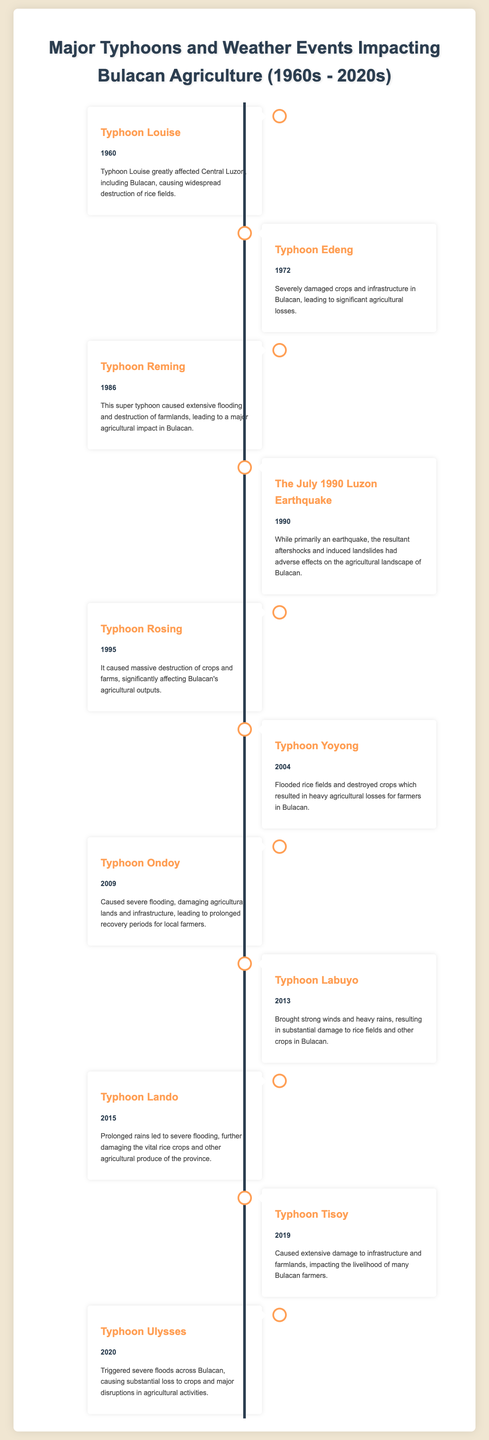What year did Typhoon Louise occur? The document states that Typhoon Louise occurred in the year 1960.
Answer: 1960 Which typhoon caused severe flooding in 2009? The document indicates that Typhoon Ondoy caused severe flooding in 2009.
Answer: Typhoon Ondoy How many typhoons are listed in the document? The document lists a total of 11 typhoons and weather events impacting Bulacan agriculture.
Answer: 11 What event occurred in 1990 besides typhoons? The document mentions that the July 1990 Luzon Earthquake occurred in 1990.
Answer: The July 1990 Luzon Earthquake Which typhoon had significant agricultural impact in 1995? The document states that Typhoon Rosing had a significant agricultural impact in 1995 by causing massive destruction of crops.
Answer: Typhoon Rosing What was a common consequence of the typhoons listed in the document? The document consistently notes widespread destruction and significant agricultural losses as common consequences of the typhoons.
Answer: Significant agricultural losses Which weather event in 2020 had a severe effect on crops? The document indicates that Typhoon Ulysses triggered severe floods and caused substantial loss to crops in 2020.
Answer: Typhoon Ulysses What is the structure of the timeline infographic? The document is structured as a timeline, displaying events alternating from left to right with notable dates and descriptions.
Answer: A timeline Which typhoon impacted Bulacan with prolonged rains in 2015? The document highlights that Typhoon Lando impacted Bulacan with prolonged rains in 2015.
Answer: Typhoon Lando 